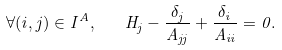Convert formula to latex. <formula><loc_0><loc_0><loc_500><loc_500>\forall ( i , j ) \in I ^ { A } , \quad H _ { j } - \frac { \delta _ { j } } { A _ { j j } } + \frac { \delta _ { i } } { A _ { i i } } = 0 .</formula> 